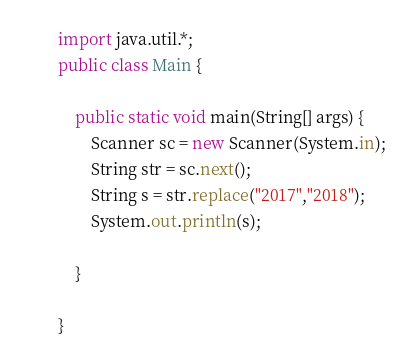<code> <loc_0><loc_0><loc_500><loc_500><_Java_>import java.util.*;
public class Main {

	public static void main(String[] args) {
		Scanner sc = new Scanner(System.in);
		String str = sc.next();
		String s = str.replace("2017","2018");
		System.out.println(s);
		
	}

}</code> 